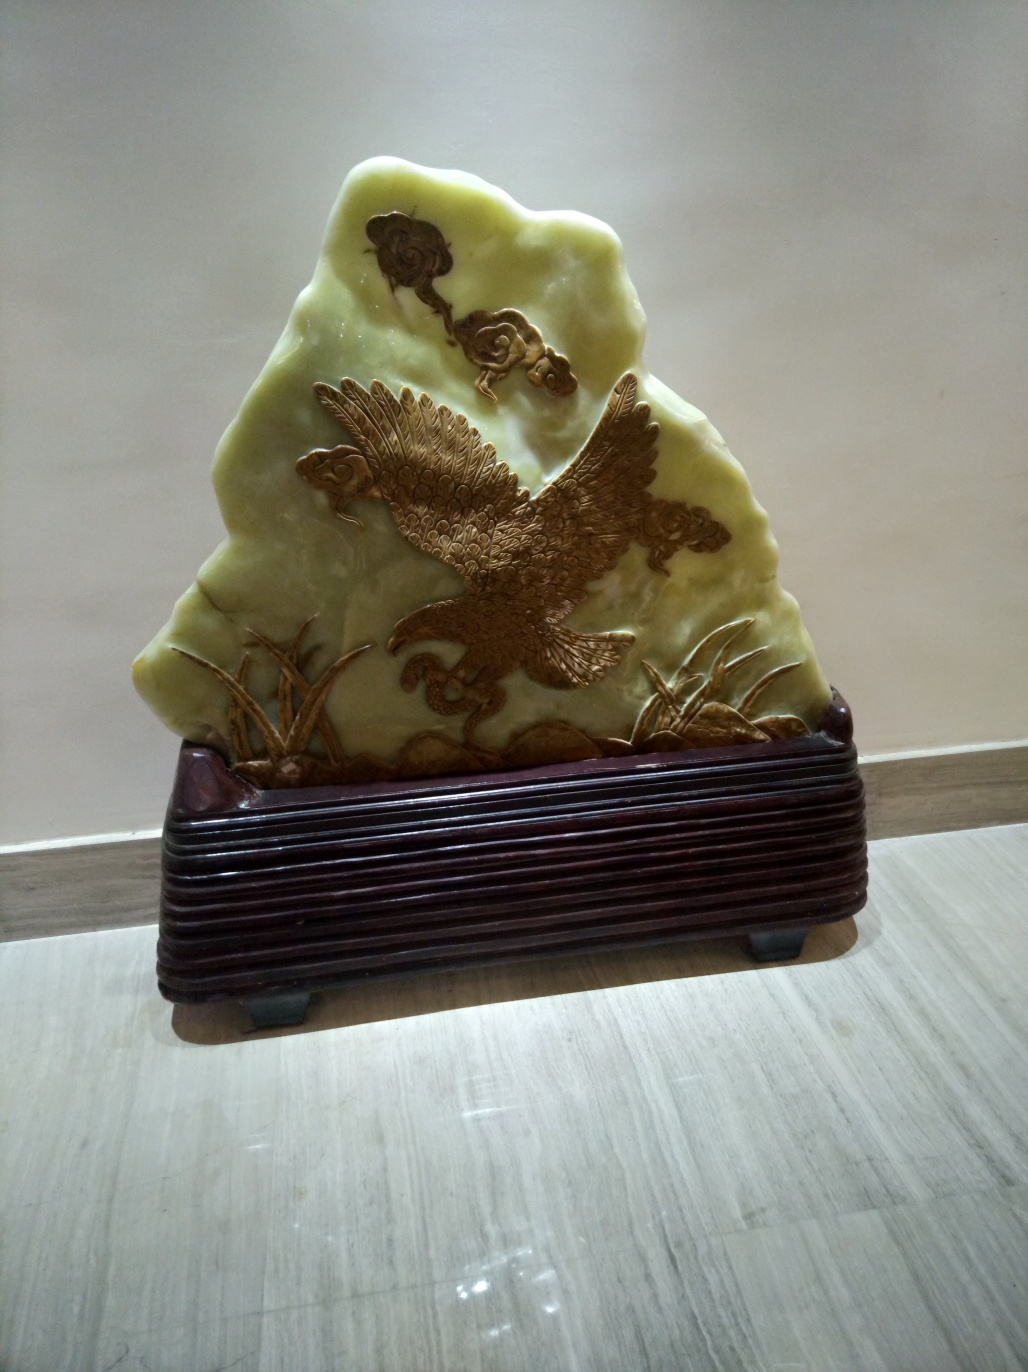What material does the object in the image appear to be made of? The object in the image seems to be made of a type of stone, likely jade, considering its translucency and color. The smooth and glossy surface suggests a polished finish, which is common in carved jade pieces. 